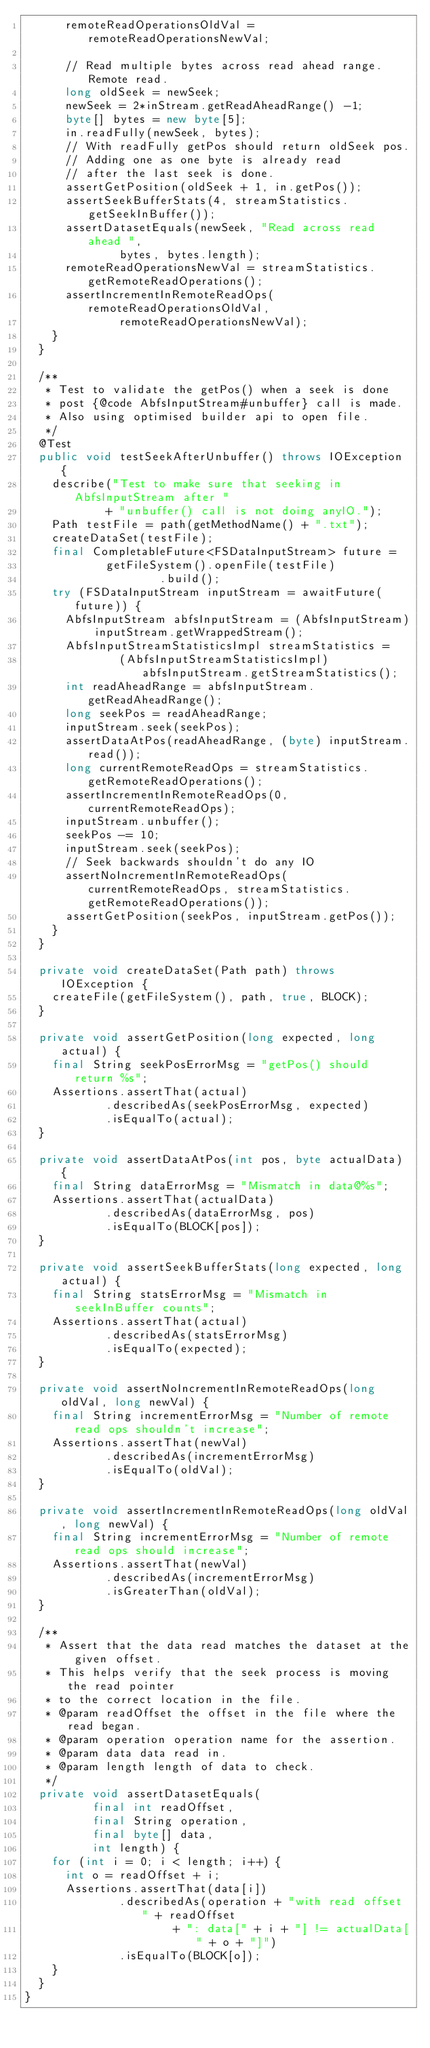Convert code to text. <code><loc_0><loc_0><loc_500><loc_500><_Java_>      remoteReadOperationsOldVal = remoteReadOperationsNewVal;

      // Read multiple bytes across read ahead range. Remote read.
      long oldSeek = newSeek;
      newSeek = 2*inStream.getReadAheadRange() -1;
      byte[] bytes = new byte[5];
      in.readFully(newSeek, bytes);
      // With readFully getPos should return oldSeek pos.
      // Adding one as one byte is already read
      // after the last seek is done.
      assertGetPosition(oldSeek + 1, in.getPos());
      assertSeekBufferStats(4, streamStatistics.getSeekInBuffer());
      assertDatasetEquals(newSeek, "Read across read ahead ",
              bytes, bytes.length);
      remoteReadOperationsNewVal = streamStatistics.getRemoteReadOperations();
      assertIncrementInRemoteReadOps(remoteReadOperationsOldVal,
              remoteReadOperationsNewVal);
    }
  }

  /**
   * Test to validate the getPos() when a seek is done
   * post {@code AbfsInputStream#unbuffer} call is made.
   * Also using optimised builder api to open file.
   */
  @Test
  public void testSeekAfterUnbuffer() throws IOException {
    describe("Test to make sure that seeking in AbfsInputStream after "
            + "unbuffer() call is not doing anyIO.");
    Path testFile = path(getMethodName() + ".txt");
    createDataSet(testFile);
    final CompletableFuture<FSDataInputStream> future =
            getFileSystem().openFile(testFile)
                    .build();
    try (FSDataInputStream inputStream = awaitFuture(future)) {
      AbfsInputStream abfsInputStream = (AbfsInputStream) inputStream.getWrappedStream();
      AbfsInputStreamStatisticsImpl streamStatistics =
              (AbfsInputStreamStatisticsImpl) abfsInputStream.getStreamStatistics();
      int readAheadRange = abfsInputStream.getReadAheadRange();
      long seekPos = readAheadRange;
      inputStream.seek(seekPos);
      assertDataAtPos(readAheadRange, (byte) inputStream.read());
      long currentRemoteReadOps = streamStatistics.getRemoteReadOperations();
      assertIncrementInRemoteReadOps(0, currentRemoteReadOps);
      inputStream.unbuffer();
      seekPos -= 10;
      inputStream.seek(seekPos);
      // Seek backwards shouldn't do any IO
      assertNoIncrementInRemoteReadOps(currentRemoteReadOps, streamStatistics.getRemoteReadOperations());
      assertGetPosition(seekPos, inputStream.getPos());
    }
  }

  private void createDataSet(Path path) throws IOException {
    createFile(getFileSystem(), path, true, BLOCK);
  }

  private void assertGetPosition(long expected, long actual) {
    final String seekPosErrorMsg = "getPos() should return %s";
    Assertions.assertThat(actual)
            .describedAs(seekPosErrorMsg, expected)
            .isEqualTo(actual);
  }

  private void assertDataAtPos(int pos, byte actualData) {
    final String dataErrorMsg = "Mismatch in data@%s";
    Assertions.assertThat(actualData)
            .describedAs(dataErrorMsg, pos)
            .isEqualTo(BLOCK[pos]);
  }

  private void assertSeekBufferStats(long expected, long actual) {
    final String statsErrorMsg = "Mismatch in seekInBuffer counts";
    Assertions.assertThat(actual)
            .describedAs(statsErrorMsg)
            .isEqualTo(expected);
  }

  private void assertNoIncrementInRemoteReadOps(long oldVal, long newVal) {
    final String incrementErrorMsg = "Number of remote read ops shouldn't increase";
    Assertions.assertThat(newVal)
            .describedAs(incrementErrorMsg)
            .isEqualTo(oldVal);
  }

  private void assertIncrementInRemoteReadOps(long oldVal, long newVal) {
    final String incrementErrorMsg = "Number of remote read ops should increase";
    Assertions.assertThat(newVal)
            .describedAs(incrementErrorMsg)
            .isGreaterThan(oldVal);
  }

  /**
   * Assert that the data read matches the dataset at the given offset.
   * This helps verify that the seek process is moving the read pointer
   * to the correct location in the file.
   * @param readOffset the offset in the file where the read began.
   * @param operation operation name for the assertion.
   * @param data data read in.
   * @param length length of data to check.
   */
  private void assertDatasetEquals(
          final int readOffset,
          final String operation,
          final byte[] data,
          int length) {
    for (int i = 0; i < length; i++) {
      int o = readOffset + i;
      Assertions.assertThat(data[i])
              .describedAs(operation + "with read offset " + readOffset
                      + ": data[" + i + "] != actualData[" + o + "]")
              .isEqualTo(BLOCK[o]);
    }
  }
}
</code> 